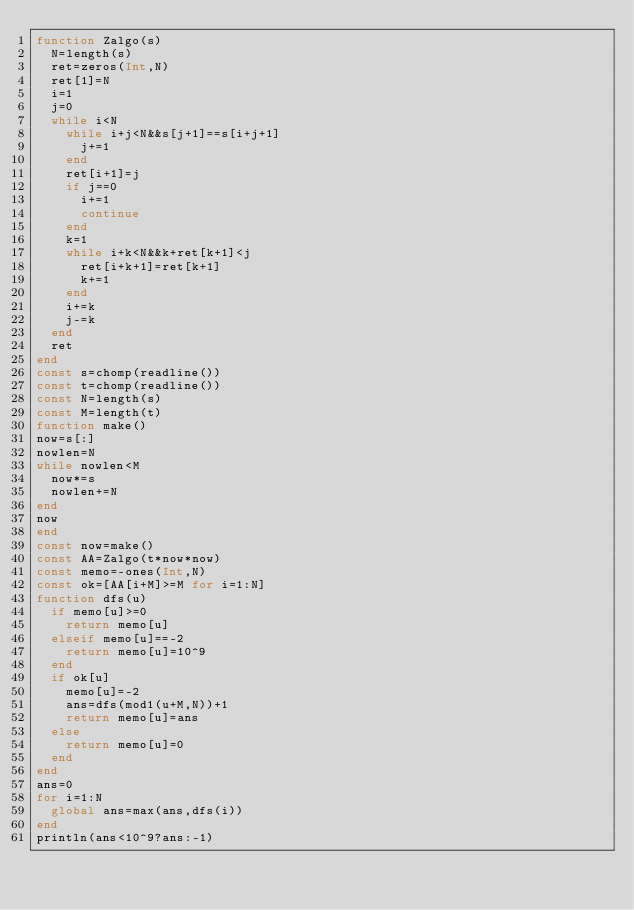Convert code to text. <code><loc_0><loc_0><loc_500><loc_500><_Julia_>function Zalgo(s)
	N=length(s)
	ret=zeros(Int,N)
	ret[1]=N
	i=1
	j=0
	while i<N
		while i+j<N&&s[j+1]==s[i+j+1]
			j+=1
		end
		ret[i+1]=j
		if j==0
			i+=1
			continue
		end
		k=1
		while i+k<N&&k+ret[k+1]<j
			ret[i+k+1]=ret[k+1]
			k+=1
		end
		i+=k
		j-=k
	end
	ret
end
const s=chomp(readline())
const t=chomp(readline())
const N=length(s)
const M=length(t)
function make()
now=s[:]
nowlen=N
while nowlen<M
	now*=s
	nowlen+=N
end
now
end
const now=make()
const AA=Zalgo(t*now*now)
const memo=-ones(Int,N)
const ok=[AA[i+M]>=M for i=1:N]
function dfs(u)
	if memo[u]>=0
		return memo[u]
	elseif memo[u]==-2
		return memo[u]=10^9
	end
	if ok[u]
		memo[u]=-2
		ans=dfs(mod1(u+M,N))+1
		return memo[u]=ans
	else
		return memo[u]=0
	end
end
ans=0
for i=1:N
	global ans=max(ans,dfs(i))
end
println(ans<10^9?ans:-1)
</code> 